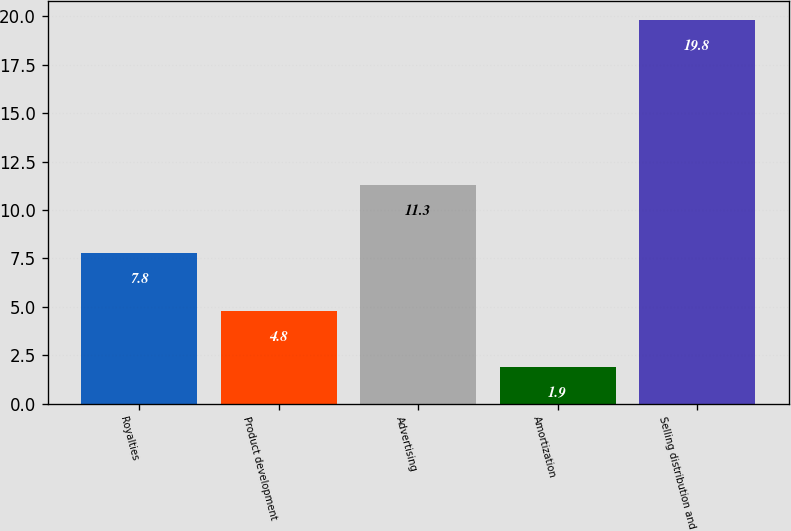<chart> <loc_0><loc_0><loc_500><loc_500><bar_chart><fcel>Royalties<fcel>Product development<fcel>Advertising<fcel>Amortization<fcel>Selling distribution and<nl><fcel>7.8<fcel>4.8<fcel>11.3<fcel>1.9<fcel>19.8<nl></chart> 